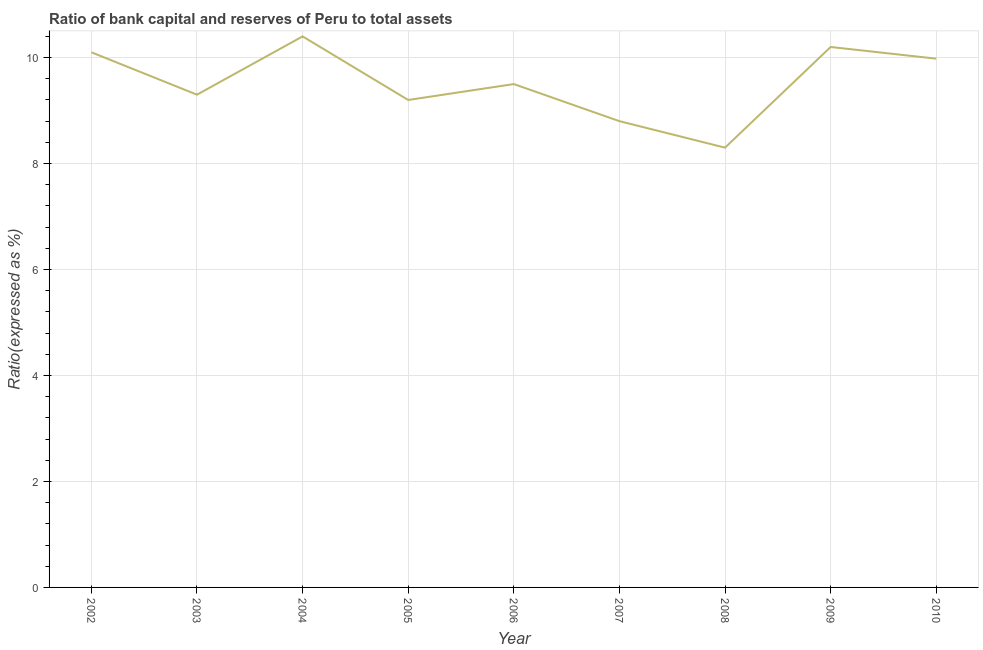Across all years, what is the maximum bank capital to assets ratio?
Ensure brevity in your answer.  10.4. In which year was the bank capital to assets ratio maximum?
Offer a very short reply. 2004. In which year was the bank capital to assets ratio minimum?
Your response must be concise. 2008. What is the sum of the bank capital to assets ratio?
Your answer should be compact. 85.78. What is the difference between the bank capital to assets ratio in 2006 and 2008?
Your answer should be very brief. 1.2. What is the average bank capital to assets ratio per year?
Ensure brevity in your answer.  9.53. What is the median bank capital to assets ratio?
Ensure brevity in your answer.  9.5. In how many years, is the bank capital to assets ratio greater than 2.4 %?
Provide a succinct answer. 9. Do a majority of the years between 2005 and 2007 (inclusive) have bank capital to assets ratio greater than 6.4 %?
Provide a succinct answer. Yes. What is the ratio of the bank capital to assets ratio in 2004 to that in 2009?
Provide a succinct answer. 1.02. Is the difference between the bank capital to assets ratio in 2005 and 2007 greater than the difference between any two years?
Provide a succinct answer. No. What is the difference between the highest and the second highest bank capital to assets ratio?
Your answer should be very brief. 0.2. What is the difference between the highest and the lowest bank capital to assets ratio?
Your answer should be very brief. 2.1. Does the bank capital to assets ratio monotonically increase over the years?
Offer a very short reply. No. What is the difference between two consecutive major ticks on the Y-axis?
Offer a very short reply. 2. Are the values on the major ticks of Y-axis written in scientific E-notation?
Ensure brevity in your answer.  No. Does the graph contain any zero values?
Give a very brief answer. No. What is the title of the graph?
Offer a very short reply. Ratio of bank capital and reserves of Peru to total assets. What is the label or title of the Y-axis?
Offer a very short reply. Ratio(expressed as %). What is the Ratio(expressed as %) of 2003?
Keep it short and to the point. 9.3. What is the Ratio(expressed as %) in 2004?
Your answer should be compact. 10.4. What is the Ratio(expressed as %) in 2006?
Give a very brief answer. 9.5. What is the Ratio(expressed as %) in 2007?
Ensure brevity in your answer.  8.8. What is the Ratio(expressed as %) of 2008?
Offer a very short reply. 8.3. What is the Ratio(expressed as %) in 2009?
Your answer should be very brief. 10.2. What is the Ratio(expressed as %) of 2010?
Your answer should be compact. 9.98. What is the difference between the Ratio(expressed as %) in 2002 and 2003?
Make the answer very short. 0.8. What is the difference between the Ratio(expressed as %) in 2002 and 2005?
Make the answer very short. 0.9. What is the difference between the Ratio(expressed as %) in 2002 and 2006?
Provide a short and direct response. 0.6. What is the difference between the Ratio(expressed as %) in 2002 and 2008?
Provide a short and direct response. 1.8. What is the difference between the Ratio(expressed as %) in 2002 and 2010?
Your answer should be compact. 0.12. What is the difference between the Ratio(expressed as %) in 2003 and 2004?
Your answer should be compact. -1.1. What is the difference between the Ratio(expressed as %) in 2003 and 2005?
Your answer should be compact. 0.1. What is the difference between the Ratio(expressed as %) in 2003 and 2006?
Your response must be concise. -0.2. What is the difference between the Ratio(expressed as %) in 2003 and 2008?
Your response must be concise. 1. What is the difference between the Ratio(expressed as %) in 2003 and 2009?
Keep it short and to the point. -0.9. What is the difference between the Ratio(expressed as %) in 2003 and 2010?
Your answer should be compact. -0.68. What is the difference between the Ratio(expressed as %) in 2004 and 2006?
Your answer should be very brief. 0.9. What is the difference between the Ratio(expressed as %) in 2004 and 2009?
Offer a terse response. 0.2. What is the difference between the Ratio(expressed as %) in 2004 and 2010?
Make the answer very short. 0.42. What is the difference between the Ratio(expressed as %) in 2005 and 2007?
Make the answer very short. 0.4. What is the difference between the Ratio(expressed as %) in 2005 and 2010?
Your answer should be compact. -0.78. What is the difference between the Ratio(expressed as %) in 2006 and 2007?
Offer a very short reply. 0.7. What is the difference between the Ratio(expressed as %) in 2006 and 2010?
Your answer should be compact. -0.48. What is the difference between the Ratio(expressed as %) in 2007 and 2008?
Your response must be concise. 0.5. What is the difference between the Ratio(expressed as %) in 2007 and 2009?
Offer a terse response. -1.4. What is the difference between the Ratio(expressed as %) in 2007 and 2010?
Provide a short and direct response. -1.18. What is the difference between the Ratio(expressed as %) in 2008 and 2009?
Keep it short and to the point. -1.9. What is the difference between the Ratio(expressed as %) in 2008 and 2010?
Make the answer very short. -1.68. What is the difference between the Ratio(expressed as %) in 2009 and 2010?
Your answer should be very brief. 0.22. What is the ratio of the Ratio(expressed as %) in 2002 to that in 2003?
Provide a succinct answer. 1.09. What is the ratio of the Ratio(expressed as %) in 2002 to that in 2004?
Offer a very short reply. 0.97. What is the ratio of the Ratio(expressed as %) in 2002 to that in 2005?
Offer a very short reply. 1.1. What is the ratio of the Ratio(expressed as %) in 2002 to that in 2006?
Your response must be concise. 1.06. What is the ratio of the Ratio(expressed as %) in 2002 to that in 2007?
Provide a short and direct response. 1.15. What is the ratio of the Ratio(expressed as %) in 2002 to that in 2008?
Your answer should be very brief. 1.22. What is the ratio of the Ratio(expressed as %) in 2003 to that in 2004?
Give a very brief answer. 0.89. What is the ratio of the Ratio(expressed as %) in 2003 to that in 2006?
Make the answer very short. 0.98. What is the ratio of the Ratio(expressed as %) in 2003 to that in 2007?
Keep it short and to the point. 1.06. What is the ratio of the Ratio(expressed as %) in 2003 to that in 2008?
Your response must be concise. 1.12. What is the ratio of the Ratio(expressed as %) in 2003 to that in 2009?
Offer a very short reply. 0.91. What is the ratio of the Ratio(expressed as %) in 2003 to that in 2010?
Make the answer very short. 0.93. What is the ratio of the Ratio(expressed as %) in 2004 to that in 2005?
Your answer should be very brief. 1.13. What is the ratio of the Ratio(expressed as %) in 2004 to that in 2006?
Your response must be concise. 1.09. What is the ratio of the Ratio(expressed as %) in 2004 to that in 2007?
Offer a very short reply. 1.18. What is the ratio of the Ratio(expressed as %) in 2004 to that in 2008?
Provide a succinct answer. 1.25. What is the ratio of the Ratio(expressed as %) in 2004 to that in 2010?
Your answer should be very brief. 1.04. What is the ratio of the Ratio(expressed as %) in 2005 to that in 2006?
Give a very brief answer. 0.97. What is the ratio of the Ratio(expressed as %) in 2005 to that in 2007?
Offer a very short reply. 1.04. What is the ratio of the Ratio(expressed as %) in 2005 to that in 2008?
Offer a terse response. 1.11. What is the ratio of the Ratio(expressed as %) in 2005 to that in 2009?
Make the answer very short. 0.9. What is the ratio of the Ratio(expressed as %) in 2005 to that in 2010?
Keep it short and to the point. 0.92. What is the ratio of the Ratio(expressed as %) in 2006 to that in 2007?
Offer a terse response. 1.08. What is the ratio of the Ratio(expressed as %) in 2006 to that in 2008?
Offer a very short reply. 1.15. What is the ratio of the Ratio(expressed as %) in 2006 to that in 2010?
Offer a terse response. 0.95. What is the ratio of the Ratio(expressed as %) in 2007 to that in 2008?
Your answer should be compact. 1.06. What is the ratio of the Ratio(expressed as %) in 2007 to that in 2009?
Your answer should be compact. 0.86. What is the ratio of the Ratio(expressed as %) in 2007 to that in 2010?
Ensure brevity in your answer.  0.88. What is the ratio of the Ratio(expressed as %) in 2008 to that in 2009?
Keep it short and to the point. 0.81. What is the ratio of the Ratio(expressed as %) in 2008 to that in 2010?
Your answer should be compact. 0.83. 